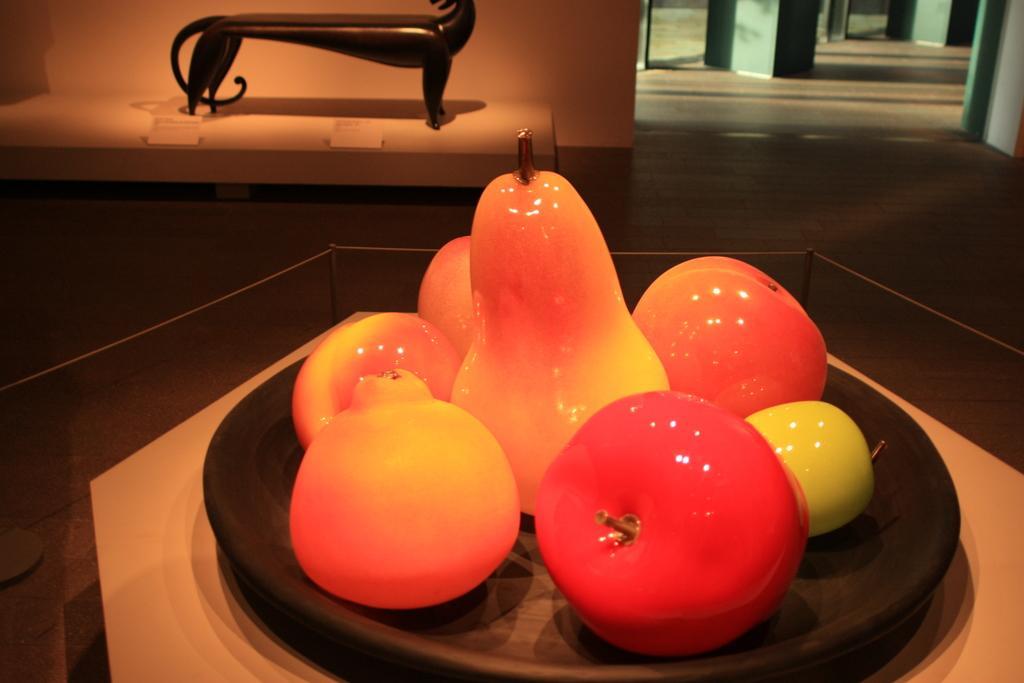Could you give a brief overview of what you see in this image? We can see pears and some fruits with plate on glass table. In the background we can see wooden object on the white surface,wall and floor. 